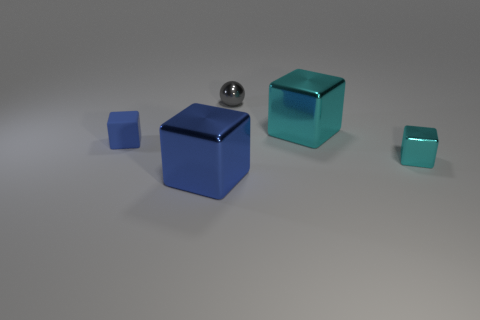How many things are in front of the small shiny cube and to the left of the blue shiny object?
Your response must be concise. 0. Is there any other thing that is the same shape as the blue metal object?
Provide a short and direct response. Yes. What size is the cyan metal object that is behind the small blue cube?
Keep it short and to the point. Large. What number of other objects are the same color as the tiny metal block?
Your response must be concise. 1. The tiny block to the left of the large block behind the blue metallic block is made of what material?
Offer a terse response. Rubber. There is a big metallic thing that is behind the tiny blue matte thing; is it the same color as the small metallic block?
Ensure brevity in your answer.  Yes. Are there any other things that are made of the same material as the tiny blue block?
Your answer should be compact. No. How many small cyan metallic objects have the same shape as the tiny gray metallic thing?
Give a very brief answer. 0. There is a blue block that is the same material as the big cyan thing; what is its size?
Ensure brevity in your answer.  Large. Is there a blue block that is in front of the cyan metal cube that is in front of the large cube behind the blue rubber object?
Make the answer very short. Yes. 